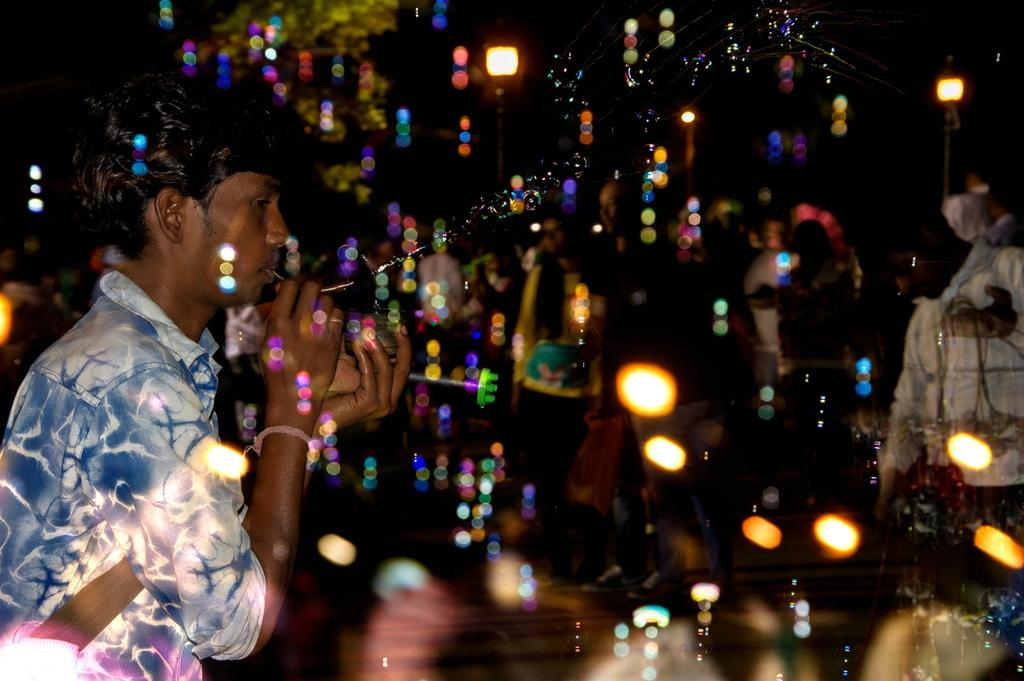What is present in the image? There is a man in the image. What is the man wearing? The man is wearing clothes. What is the man doing with the object in his mouth? The man is holding an object in his mouth. What else can be seen in the image besides the man? There are foam bubbles and light visible in the image. How would you describe the background of the image? The background of the image is dark and blurred. What type of silver is the scarecrow holding in the image? There is no scarecrow or silver present in the image. What show is the man performing in the image? The image does not indicate that the man is performing in a show. 